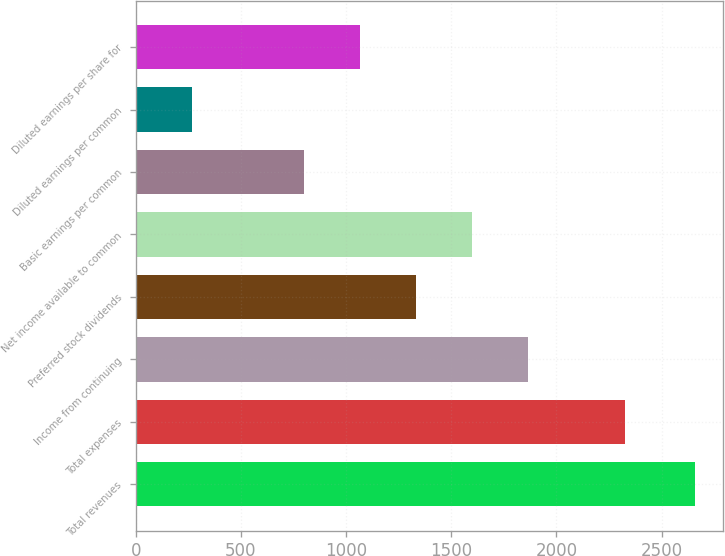Convert chart. <chart><loc_0><loc_0><loc_500><loc_500><bar_chart><fcel>Total revenues<fcel>Total expenses<fcel>Income from continuing<fcel>Preferred stock dividends<fcel>Net income available to common<fcel>Basic earnings per common<fcel>Diluted earnings per common<fcel>Diluted earnings per share for<nl><fcel>2661<fcel>2326.7<fcel>1863.02<fcel>1331<fcel>1597.01<fcel>798.98<fcel>266.96<fcel>1064.99<nl></chart> 